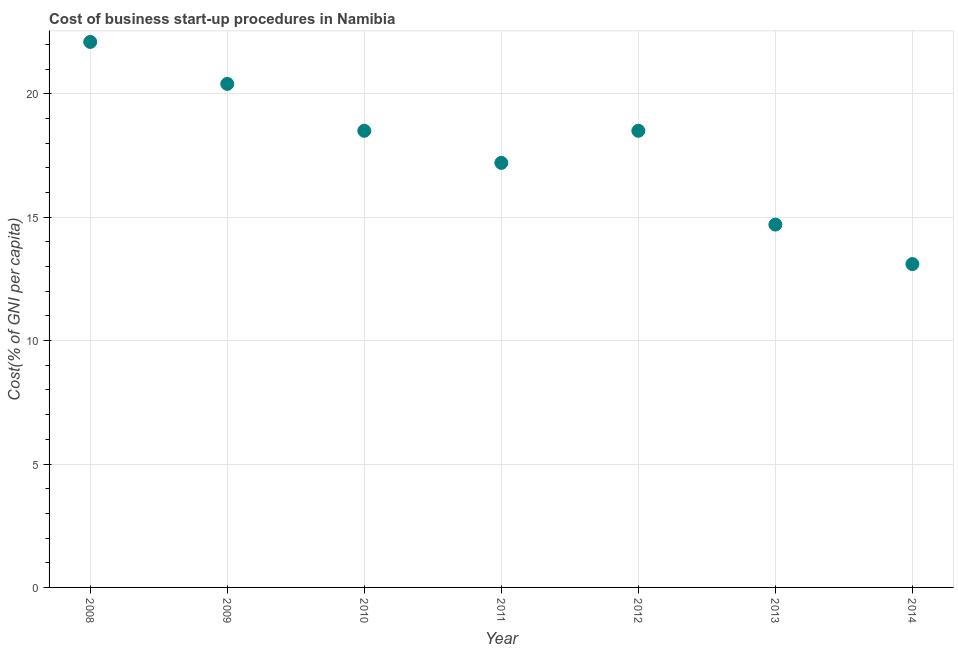What is the cost of business startup procedures in 2008?
Ensure brevity in your answer.  22.1. Across all years, what is the maximum cost of business startup procedures?
Give a very brief answer. 22.1. In which year was the cost of business startup procedures minimum?
Offer a very short reply. 2014. What is the sum of the cost of business startup procedures?
Your answer should be very brief. 124.5. What is the difference between the cost of business startup procedures in 2013 and 2014?
Offer a very short reply. 1.6. What is the average cost of business startup procedures per year?
Offer a terse response. 17.79. In how many years, is the cost of business startup procedures greater than 1 %?
Keep it short and to the point. 7. What is the ratio of the cost of business startup procedures in 2008 to that in 2014?
Your response must be concise. 1.69. What is the difference between the highest and the second highest cost of business startup procedures?
Your response must be concise. 1.7. What is the difference between the highest and the lowest cost of business startup procedures?
Keep it short and to the point. 9. In how many years, is the cost of business startup procedures greater than the average cost of business startup procedures taken over all years?
Keep it short and to the point. 4. Does the cost of business startup procedures monotonically increase over the years?
Your answer should be compact. No. How many years are there in the graph?
Your answer should be compact. 7. What is the difference between two consecutive major ticks on the Y-axis?
Make the answer very short. 5. Are the values on the major ticks of Y-axis written in scientific E-notation?
Make the answer very short. No. Does the graph contain any zero values?
Keep it short and to the point. No. What is the title of the graph?
Provide a short and direct response. Cost of business start-up procedures in Namibia. What is the label or title of the X-axis?
Your response must be concise. Year. What is the label or title of the Y-axis?
Give a very brief answer. Cost(% of GNI per capita). What is the Cost(% of GNI per capita) in 2008?
Provide a short and direct response. 22.1. What is the Cost(% of GNI per capita) in 2009?
Provide a succinct answer. 20.4. What is the Cost(% of GNI per capita) in 2012?
Provide a short and direct response. 18.5. What is the Cost(% of GNI per capita) in 2013?
Give a very brief answer. 14.7. What is the Cost(% of GNI per capita) in 2014?
Your answer should be very brief. 13.1. What is the difference between the Cost(% of GNI per capita) in 2008 and 2011?
Provide a short and direct response. 4.9. What is the difference between the Cost(% of GNI per capita) in 2008 and 2012?
Your response must be concise. 3.6. What is the difference between the Cost(% of GNI per capita) in 2008 and 2013?
Your answer should be compact. 7.4. What is the difference between the Cost(% of GNI per capita) in 2008 and 2014?
Ensure brevity in your answer.  9. What is the difference between the Cost(% of GNI per capita) in 2009 and 2010?
Ensure brevity in your answer.  1.9. What is the difference between the Cost(% of GNI per capita) in 2009 and 2011?
Make the answer very short. 3.2. What is the difference between the Cost(% of GNI per capita) in 2009 and 2012?
Offer a very short reply. 1.9. What is the difference between the Cost(% of GNI per capita) in 2009 and 2013?
Offer a very short reply. 5.7. What is the difference between the Cost(% of GNI per capita) in 2009 and 2014?
Keep it short and to the point. 7.3. What is the difference between the Cost(% of GNI per capita) in 2010 and 2011?
Offer a very short reply. 1.3. What is the difference between the Cost(% of GNI per capita) in 2010 and 2012?
Provide a short and direct response. 0. What is the difference between the Cost(% of GNI per capita) in 2011 and 2012?
Offer a terse response. -1.3. What is the ratio of the Cost(% of GNI per capita) in 2008 to that in 2009?
Provide a short and direct response. 1.08. What is the ratio of the Cost(% of GNI per capita) in 2008 to that in 2010?
Give a very brief answer. 1.2. What is the ratio of the Cost(% of GNI per capita) in 2008 to that in 2011?
Offer a very short reply. 1.28. What is the ratio of the Cost(% of GNI per capita) in 2008 to that in 2012?
Your answer should be compact. 1.2. What is the ratio of the Cost(% of GNI per capita) in 2008 to that in 2013?
Provide a succinct answer. 1.5. What is the ratio of the Cost(% of GNI per capita) in 2008 to that in 2014?
Keep it short and to the point. 1.69. What is the ratio of the Cost(% of GNI per capita) in 2009 to that in 2010?
Offer a terse response. 1.1. What is the ratio of the Cost(% of GNI per capita) in 2009 to that in 2011?
Your answer should be very brief. 1.19. What is the ratio of the Cost(% of GNI per capita) in 2009 to that in 2012?
Keep it short and to the point. 1.1. What is the ratio of the Cost(% of GNI per capita) in 2009 to that in 2013?
Give a very brief answer. 1.39. What is the ratio of the Cost(% of GNI per capita) in 2009 to that in 2014?
Your response must be concise. 1.56. What is the ratio of the Cost(% of GNI per capita) in 2010 to that in 2011?
Make the answer very short. 1.08. What is the ratio of the Cost(% of GNI per capita) in 2010 to that in 2012?
Your answer should be very brief. 1. What is the ratio of the Cost(% of GNI per capita) in 2010 to that in 2013?
Offer a very short reply. 1.26. What is the ratio of the Cost(% of GNI per capita) in 2010 to that in 2014?
Offer a terse response. 1.41. What is the ratio of the Cost(% of GNI per capita) in 2011 to that in 2013?
Offer a very short reply. 1.17. What is the ratio of the Cost(% of GNI per capita) in 2011 to that in 2014?
Offer a terse response. 1.31. What is the ratio of the Cost(% of GNI per capita) in 2012 to that in 2013?
Ensure brevity in your answer.  1.26. What is the ratio of the Cost(% of GNI per capita) in 2012 to that in 2014?
Offer a terse response. 1.41. What is the ratio of the Cost(% of GNI per capita) in 2013 to that in 2014?
Ensure brevity in your answer.  1.12. 